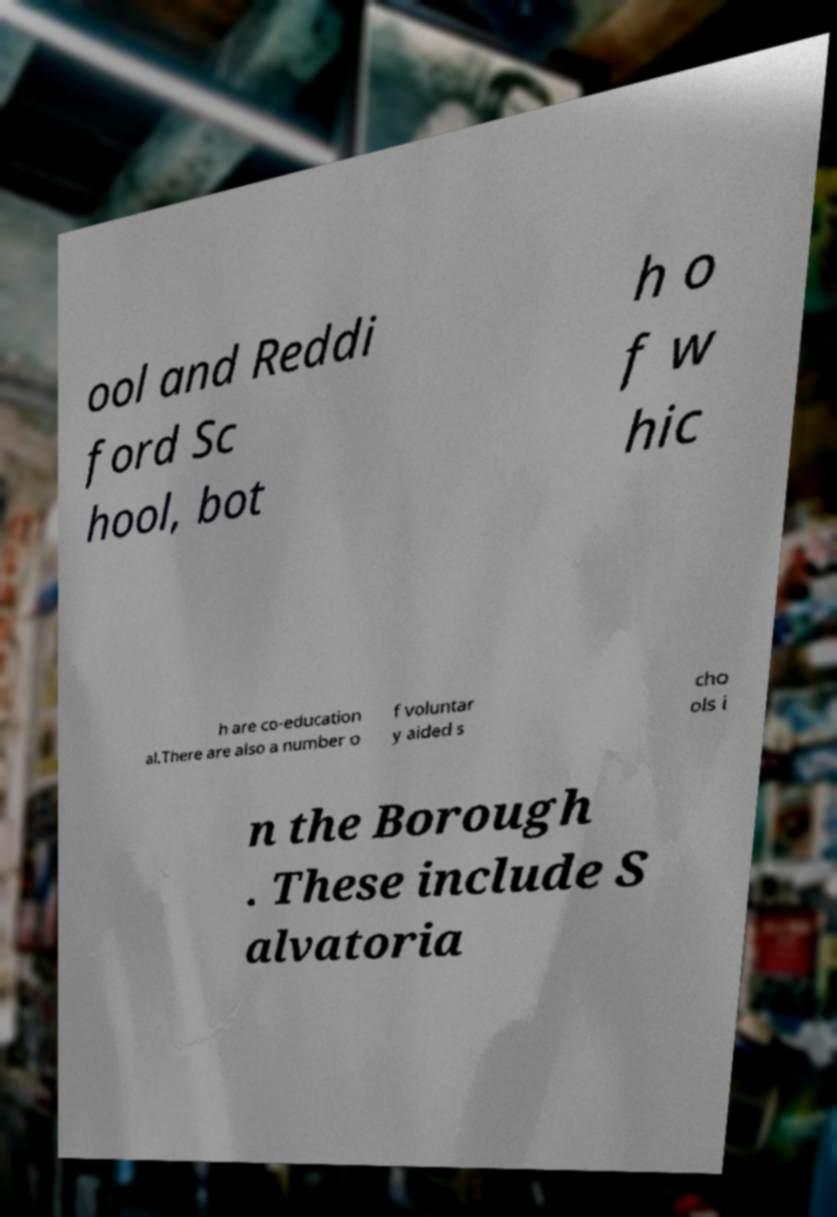Can you accurately transcribe the text from the provided image for me? ool and Reddi ford Sc hool, bot h o f w hic h are co-education al.There are also a number o f voluntar y aided s cho ols i n the Borough . These include S alvatoria 